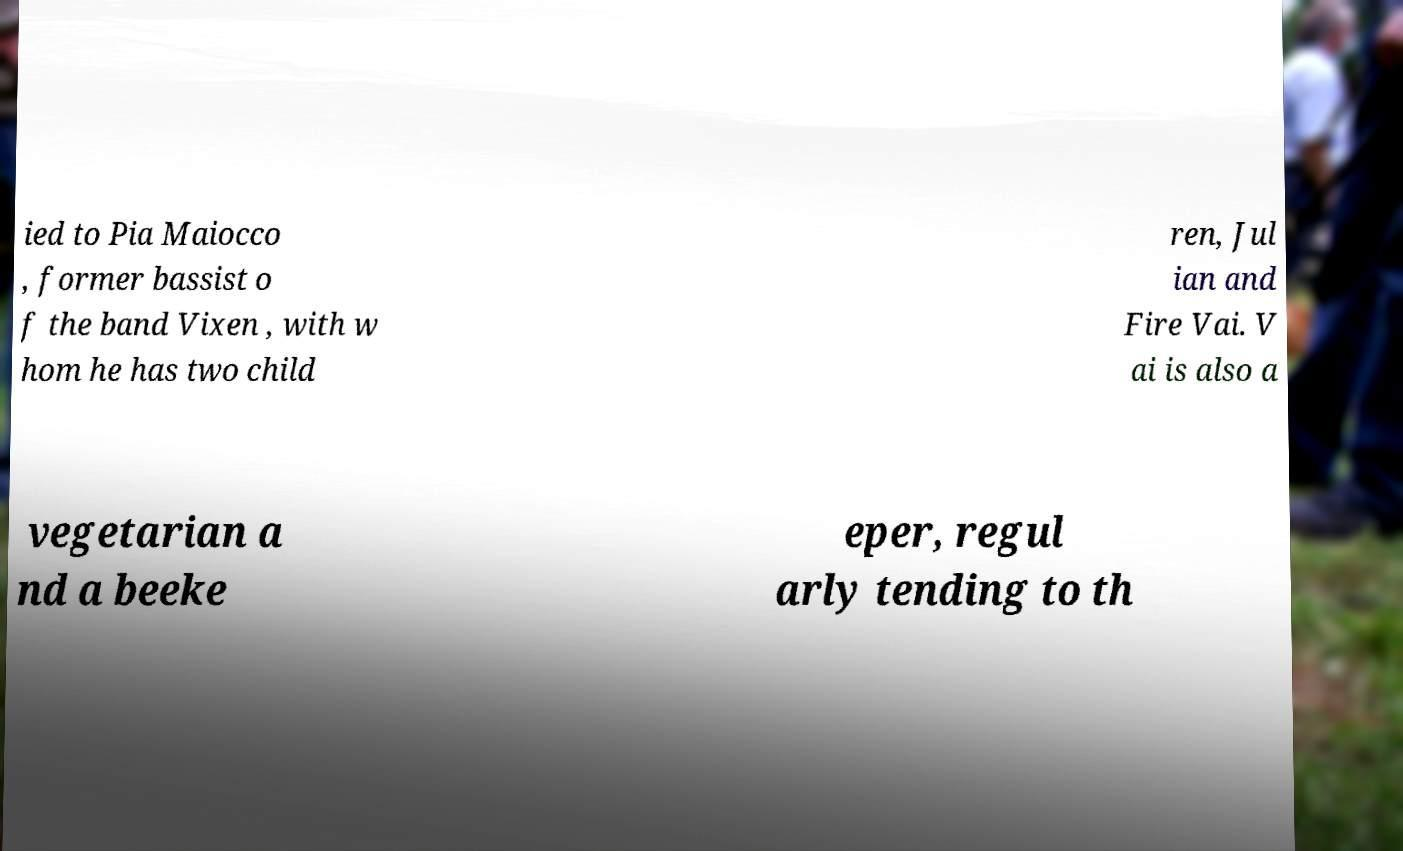I need the written content from this picture converted into text. Can you do that? ied to Pia Maiocco , former bassist o f the band Vixen , with w hom he has two child ren, Jul ian and Fire Vai. V ai is also a vegetarian a nd a beeke eper, regul arly tending to th 